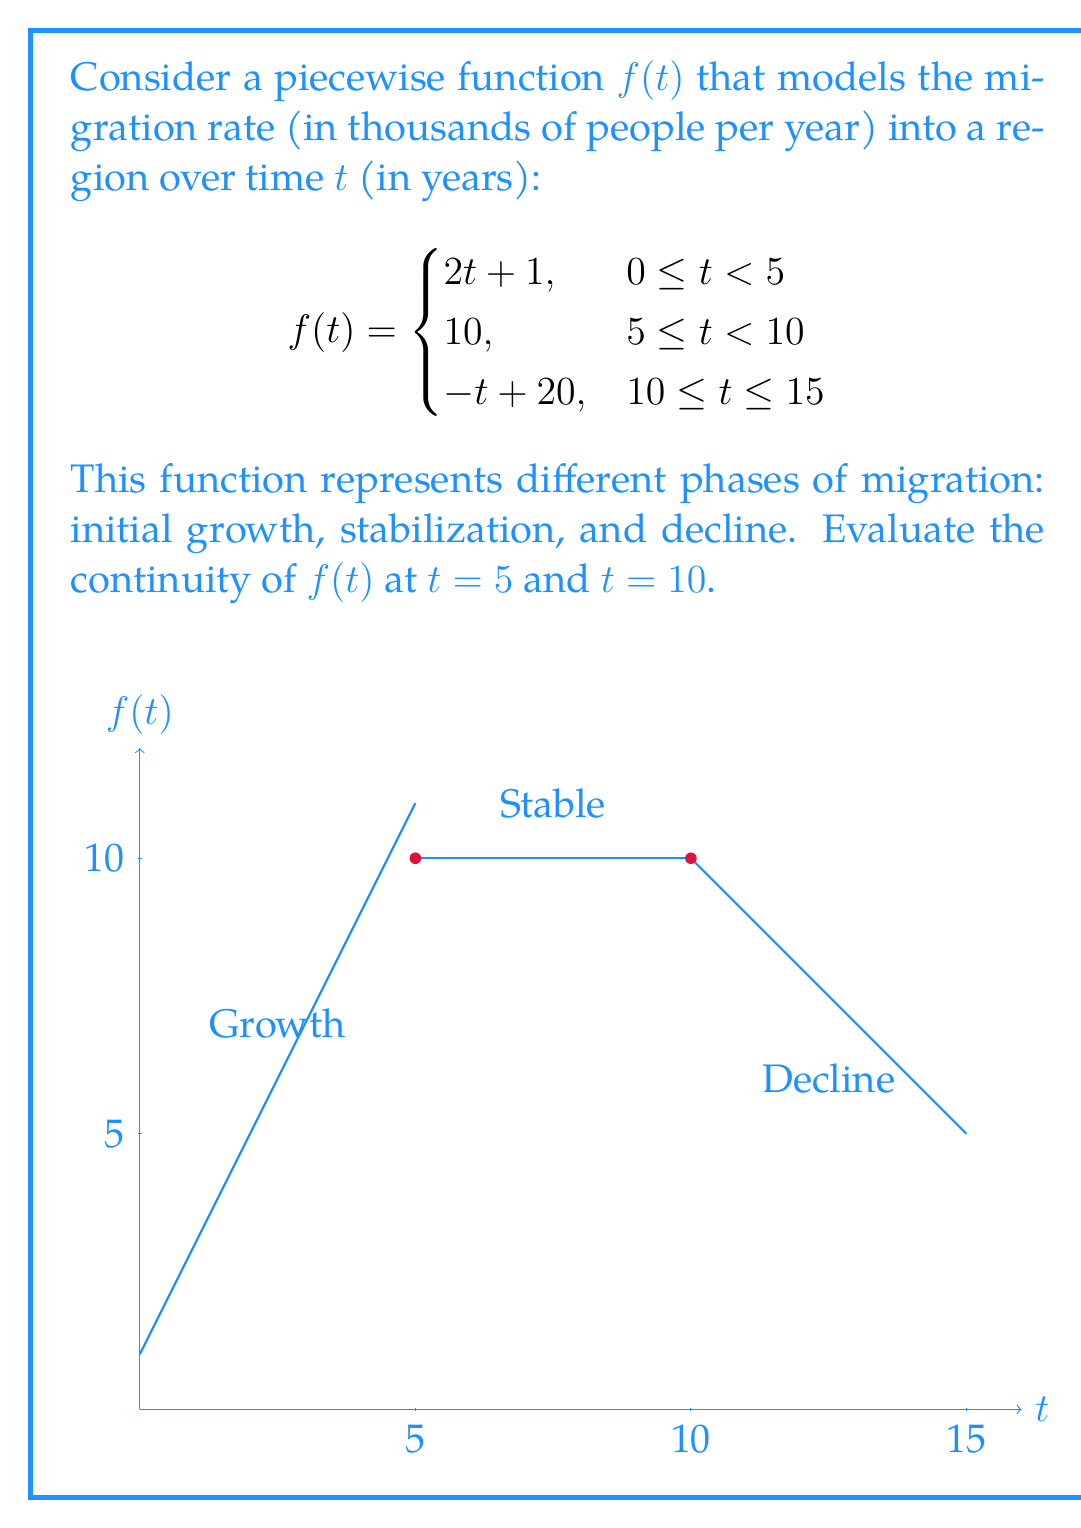Provide a solution to this math problem. To evaluate the continuity of $f(t)$ at $t = 5$ and $t = 10$, we need to check if the function satisfies the three conditions for continuity at these points:

1. The function is defined at the point.
2. The limit of the function as we approach the point from both sides exists.
3. The limit equals the function value at that point.

For $t = 5$:

1. $f(5)$ is defined: $f(5) = 10$ (using the second piece of the function).

2. Left-hand limit:
   $\lim_{t \to 5^-} f(t) = \lim_{t \to 5^-} (2t + 1) = 2(5) + 1 = 11$

   Right-hand limit:
   $\lim_{t \to 5^+} f(t) = \lim_{t \to 5^+} 10 = 10$

3. $\lim_{t \to 5^-} f(t) \neq \lim_{t \to 5^+} f(t) \neq f(5)$

Therefore, $f(t)$ is not continuous at $t = 5$.

For $t = 10$:

1. $f(10)$ is defined: $f(10) = 10$ (using either the second or third piece of the function).

2. Left-hand limit:
   $\lim_{t \to 10^-} f(t) = \lim_{t \to 10^-} 10 = 10$

   Right-hand limit:
   $\lim_{t \to 10^+} f(t) = \lim_{t \to 10^+} (-t + 20) = -10 + 20 = 10$

3. $\lim_{t \to 10^-} f(t) = \lim_{t \to 10^+} f(t) = f(10) = 10$

Therefore, $f(t)$ is continuous at $t = 10$.
Answer: $f(t)$ is discontinuous at $t = 5$ and continuous at $t = 10$. 